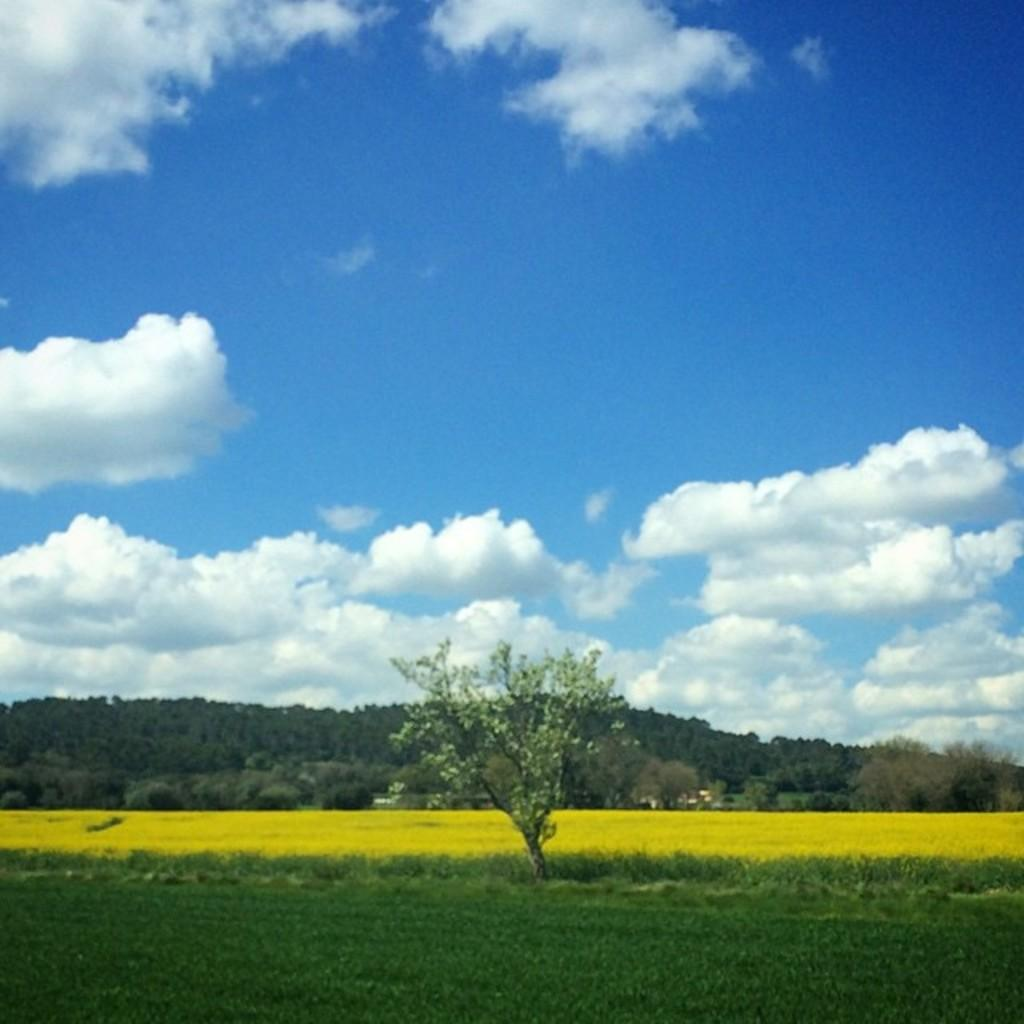What type of vegetation is present in the image? There is grass in the image. What other natural elements can be seen in the image? There are trees and hills in the image. What is visible in the background of the image? The sky is visible in the image. What can be observed in the sky? There are clouds in the sky. What is the twist rate of the mountain in the image? There is no mountain present in the image, so the twist rate cannot be determined. 